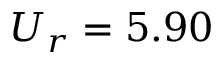<formula> <loc_0><loc_0><loc_500><loc_500>U _ { r } = 5 . 9 0</formula> 